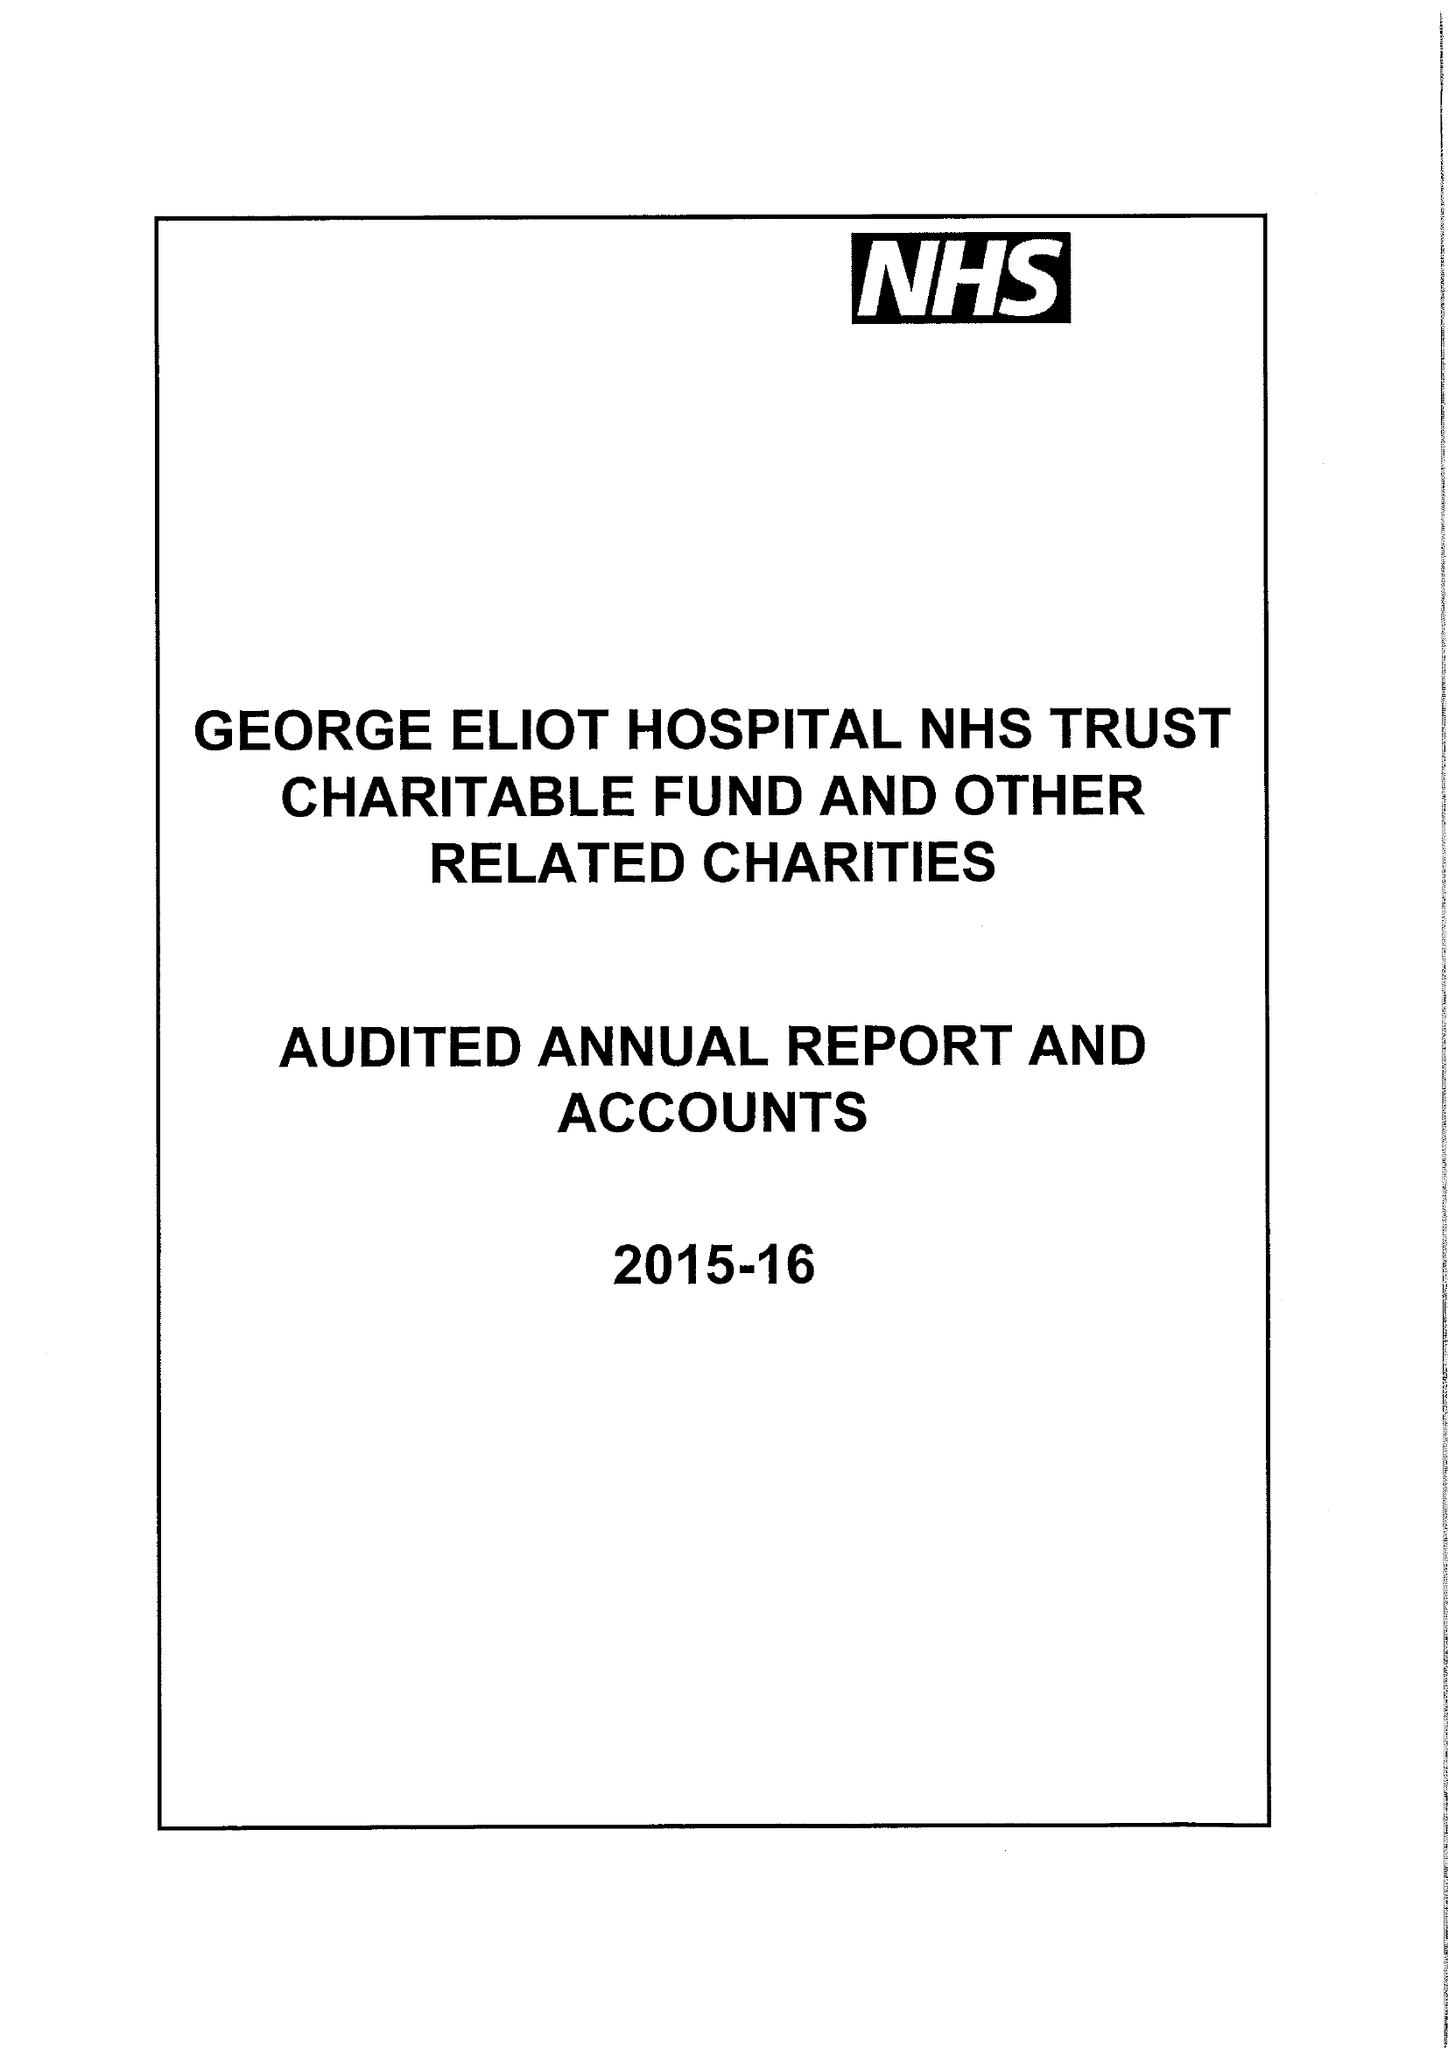What is the value for the report_date?
Answer the question using a single word or phrase. 2016-03-31 